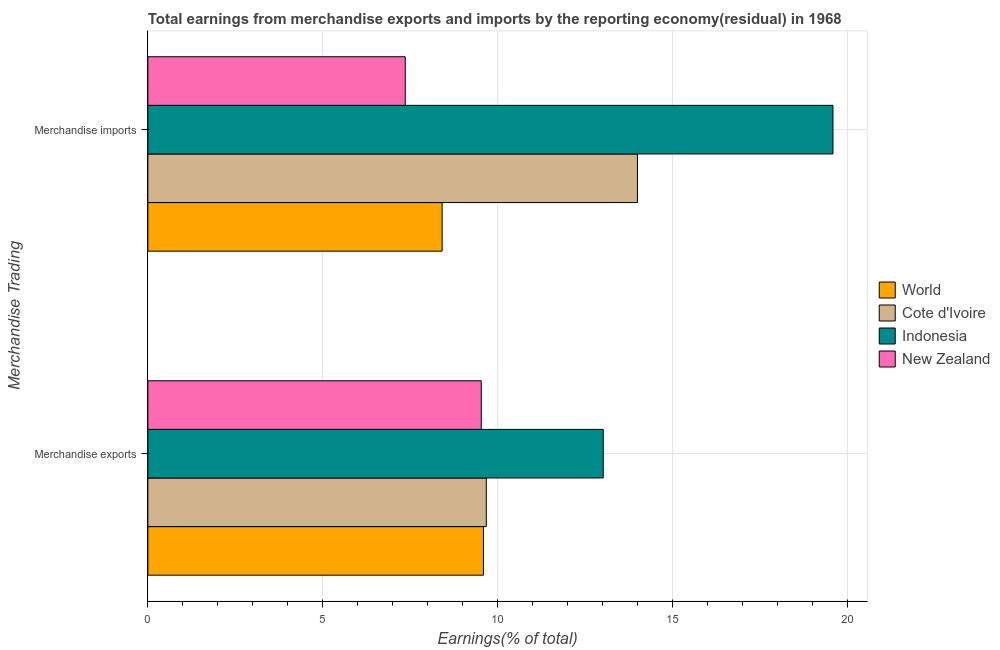How many different coloured bars are there?
Provide a succinct answer. 4. Are the number of bars per tick equal to the number of legend labels?
Your answer should be compact. Yes. How many bars are there on the 1st tick from the bottom?
Keep it short and to the point. 4. What is the earnings from merchandise imports in Cote d'Ivoire?
Ensure brevity in your answer.  14. Across all countries, what is the maximum earnings from merchandise imports?
Offer a very short reply. 19.6. Across all countries, what is the minimum earnings from merchandise imports?
Provide a short and direct response. 7.36. In which country was the earnings from merchandise exports maximum?
Your response must be concise. Indonesia. In which country was the earnings from merchandise exports minimum?
Ensure brevity in your answer.  New Zealand. What is the total earnings from merchandise imports in the graph?
Give a very brief answer. 49.38. What is the difference between the earnings from merchandise imports in Cote d'Ivoire and that in World?
Give a very brief answer. 5.59. What is the difference between the earnings from merchandise exports in Cote d'Ivoire and the earnings from merchandise imports in New Zealand?
Offer a terse response. 2.32. What is the average earnings from merchandise exports per country?
Offer a terse response. 10.46. What is the difference between the earnings from merchandise exports and earnings from merchandise imports in Indonesia?
Your response must be concise. -6.57. In how many countries, is the earnings from merchandise imports greater than 12 %?
Ensure brevity in your answer.  2. What is the ratio of the earnings from merchandise imports in New Zealand to that in Cote d'Ivoire?
Provide a succinct answer. 0.53. Is the earnings from merchandise imports in New Zealand less than that in Indonesia?
Your answer should be very brief. Yes. In how many countries, is the earnings from merchandise imports greater than the average earnings from merchandise imports taken over all countries?
Your response must be concise. 2. What does the 1st bar from the top in Merchandise imports represents?
Offer a terse response. New Zealand. What does the 4th bar from the bottom in Merchandise imports represents?
Ensure brevity in your answer.  New Zealand. How many bars are there?
Offer a terse response. 8. Are all the bars in the graph horizontal?
Offer a terse response. Yes. What is the difference between two consecutive major ticks on the X-axis?
Your response must be concise. 5. Are the values on the major ticks of X-axis written in scientific E-notation?
Your answer should be compact. No. Does the graph contain grids?
Keep it short and to the point. Yes. How are the legend labels stacked?
Your answer should be compact. Vertical. What is the title of the graph?
Offer a very short reply. Total earnings from merchandise exports and imports by the reporting economy(residual) in 1968. Does "Kiribati" appear as one of the legend labels in the graph?
Make the answer very short. No. What is the label or title of the X-axis?
Give a very brief answer. Earnings(% of total). What is the label or title of the Y-axis?
Provide a short and direct response. Merchandise Trading. What is the Earnings(% of total) in World in Merchandise exports?
Provide a short and direct response. 9.6. What is the Earnings(% of total) in Cote d'Ivoire in Merchandise exports?
Provide a short and direct response. 9.68. What is the Earnings(% of total) of Indonesia in Merchandise exports?
Your response must be concise. 13.03. What is the Earnings(% of total) in New Zealand in Merchandise exports?
Provide a succinct answer. 9.54. What is the Earnings(% of total) of World in Merchandise imports?
Your response must be concise. 8.42. What is the Earnings(% of total) in Cote d'Ivoire in Merchandise imports?
Ensure brevity in your answer.  14. What is the Earnings(% of total) of Indonesia in Merchandise imports?
Give a very brief answer. 19.6. What is the Earnings(% of total) of New Zealand in Merchandise imports?
Make the answer very short. 7.36. Across all Merchandise Trading, what is the maximum Earnings(% of total) of World?
Your response must be concise. 9.6. Across all Merchandise Trading, what is the maximum Earnings(% of total) in Cote d'Ivoire?
Your response must be concise. 14. Across all Merchandise Trading, what is the maximum Earnings(% of total) in Indonesia?
Give a very brief answer. 19.6. Across all Merchandise Trading, what is the maximum Earnings(% of total) of New Zealand?
Your response must be concise. 9.54. Across all Merchandise Trading, what is the minimum Earnings(% of total) of World?
Provide a short and direct response. 8.42. Across all Merchandise Trading, what is the minimum Earnings(% of total) in Cote d'Ivoire?
Your answer should be very brief. 9.68. Across all Merchandise Trading, what is the minimum Earnings(% of total) in Indonesia?
Offer a terse response. 13.03. Across all Merchandise Trading, what is the minimum Earnings(% of total) of New Zealand?
Your response must be concise. 7.36. What is the total Earnings(% of total) of World in the graph?
Your response must be concise. 18.01. What is the total Earnings(% of total) in Cote d'Ivoire in the graph?
Make the answer very short. 23.68. What is the total Earnings(% of total) of Indonesia in the graph?
Provide a succinct answer. 32.62. What is the total Earnings(% of total) of New Zealand in the graph?
Offer a very short reply. 16.9. What is the difference between the Earnings(% of total) in World in Merchandise exports and that in Merchandise imports?
Ensure brevity in your answer.  1.18. What is the difference between the Earnings(% of total) of Cote d'Ivoire in Merchandise exports and that in Merchandise imports?
Your answer should be very brief. -4.32. What is the difference between the Earnings(% of total) in Indonesia in Merchandise exports and that in Merchandise imports?
Your answer should be compact. -6.57. What is the difference between the Earnings(% of total) in New Zealand in Merchandise exports and that in Merchandise imports?
Give a very brief answer. 2.17. What is the difference between the Earnings(% of total) of World in Merchandise exports and the Earnings(% of total) of Cote d'Ivoire in Merchandise imports?
Ensure brevity in your answer.  -4.41. What is the difference between the Earnings(% of total) in World in Merchandise exports and the Earnings(% of total) in Indonesia in Merchandise imports?
Your answer should be very brief. -10. What is the difference between the Earnings(% of total) of World in Merchandise exports and the Earnings(% of total) of New Zealand in Merchandise imports?
Keep it short and to the point. 2.24. What is the difference between the Earnings(% of total) in Cote d'Ivoire in Merchandise exports and the Earnings(% of total) in Indonesia in Merchandise imports?
Offer a very short reply. -9.92. What is the difference between the Earnings(% of total) in Cote d'Ivoire in Merchandise exports and the Earnings(% of total) in New Zealand in Merchandise imports?
Make the answer very short. 2.32. What is the difference between the Earnings(% of total) in Indonesia in Merchandise exports and the Earnings(% of total) in New Zealand in Merchandise imports?
Offer a very short reply. 5.66. What is the average Earnings(% of total) of World per Merchandise Trading?
Provide a short and direct response. 9.01. What is the average Earnings(% of total) of Cote d'Ivoire per Merchandise Trading?
Provide a succinct answer. 11.84. What is the average Earnings(% of total) in Indonesia per Merchandise Trading?
Make the answer very short. 16.31. What is the average Earnings(% of total) of New Zealand per Merchandise Trading?
Your answer should be compact. 8.45. What is the difference between the Earnings(% of total) of World and Earnings(% of total) of Cote d'Ivoire in Merchandise exports?
Offer a very short reply. -0.08. What is the difference between the Earnings(% of total) of World and Earnings(% of total) of Indonesia in Merchandise exports?
Your response must be concise. -3.43. What is the difference between the Earnings(% of total) in World and Earnings(% of total) in New Zealand in Merchandise exports?
Your response must be concise. 0.06. What is the difference between the Earnings(% of total) of Cote d'Ivoire and Earnings(% of total) of Indonesia in Merchandise exports?
Keep it short and to the point. -3.35. What is the difference between the Earnings(% of total) in Cote d'Ivoire and Earnings(% of total) in New Zealand in Merchandise exports?
Offer a very short reply. 0.14. What is the difference between the Earnings(% of total) of Indonesia and Earnings(% of total) of New Zealand in Merchandise exports?
Give a very brief answer. 3.49. What is the difference between the Earnings(% of total) of World and Earnings(% of total) of Cote d'Ivoire in Merchandise imports?
Offer a very short reply. -5.59. What is the difference between the Earnings(% of total) of World and Earnings(% of total) of Indonesia in Merchandise imports?
Provide a short and direct response. -11.18. What is the difference between the Earnings(% of total) in World and Earnings(% of total) in New Zealand in Merchandise imports?
Give a very brief answer. 1.05. What is the difference between the Earnings(% of total) in Cote d'Ivoire and Earnings(% of total) in Indonesia in Merchandise imports?
Keep it short and to the point. -5.59. What is the difference between the Earnings(% of total) of Cote d'Ivoire and Earnings(% of total) of New Zealand in Merchandise imports?
Keep it short and to the point. 6.64. What is the difference between the Earnings(% of total) in Indonesia and Earnings(% of total) in New Zealand in Merchandise imports?
Your response must be concise. 12.23. What is the ratio of the Earnings(% of total) in World in Merchandise exports to that in Merchandise imports?
Offer a very short reply. 1.14. What is the ratio of the Earnings(% of total) in Cote d'Ivoire in Merchandise exports to that in Merchandise imports?
Offer a very short reply. 0.69. What is the ratio of the Earnings(% of total) of Indonesia in Merchandise exports to that in Merchandise imports?
Make the answer very short. 0.66. What is the ratio of the Earnings(% of total) in New Zealand in Merchandise exports to that in Merchandise imports?
Give a very brief answer. 1.3. What is the difference between the highest and the second highest Earnings(% of total) in World?
Your answer should be very brief. 1.18. What is the difference between the highest and the second highest Earnings(% of total) in Cote d'Ivoire?
Offer a very short reply. 4.32. What is the difference between the highest and the second highest Earnings(% of total) in Indonesia?
Offer a terse response. 6.57. What is the difference between the highest and the second highest Earnings(% of total) of New Zealand?
Your answer should be compact. 2.17. What is the difference between the highest and the lowest Earnings(% of total) in World?
Your response must be concise. 1.18. What is the difference between the highest and the lowest Earnings(% of total) of Cote d'Ivoire?
Ensure brevity in your answer.  4.32. What is the difference between the highest and the lowest Earnings(% of total) in Indonesia?
Your answer should be very brief. 6.57. What is the difference between the highest and the lowest Earnings(% of total) in New Zealand?
Ensure brevity in your answer.  2.17. 